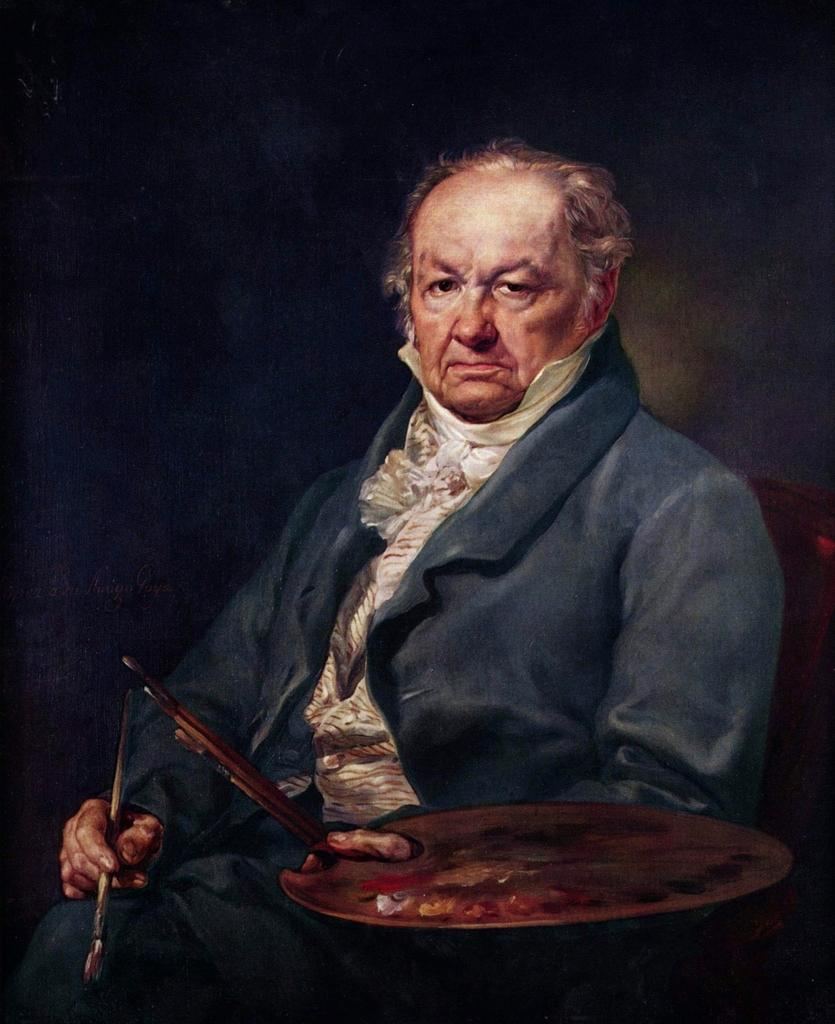What is the man in the image doing? The man is sitting in the image and holding a paintbrush. What else is the man holding in the image? The man is also holding a paint palette. What can be observed about the background of the image? The background of the image is dark. What type of meat is the man cooking in the image? There is no meat or cooking activity present in the image; the man is holding a paintbrush and a paint palette. What act is the man performing in the image? The man is sitting and holding a paintbrush and a paint palette, but there is no specific act being performed. 